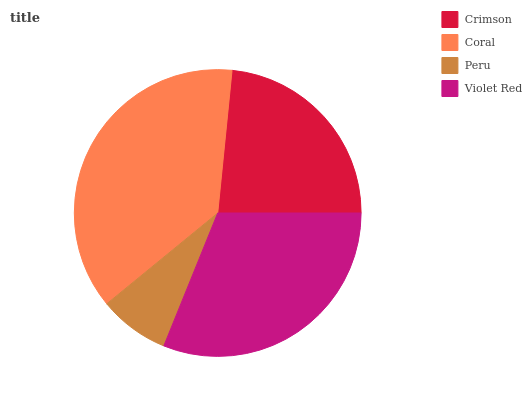Is Peru the minimum?
Answer yes or no. Yes. Is Coral the maximum?
Answer yes or no. Yes. Is Coral the minimum?
Answer yes or no. No. Is Peru the maximum?
Answer yes or no. No. Is Coral greater than Peru?
Answer yes or no. Yes. Is Peru less than Coral?
Answer yes or no. Yes. Is Peru greater than Coral?
Answer yes or no. No. Is Coral less than Peru?
Answer yes or no. No. Is Violet Red the high median?
Answer yes or no. Yes. Is Crimson the low median?
Answer yes or no. Yes. Is Crimson the high median?
Answer yes or no. No. Is Violet Red the low median?
Answer yes or no. No. 